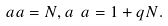Convert formula to latex. <formula><loc_0><loc_0><loc_500><loc_500>\ a a = N , a \ a = 1 + q N .</formula> 